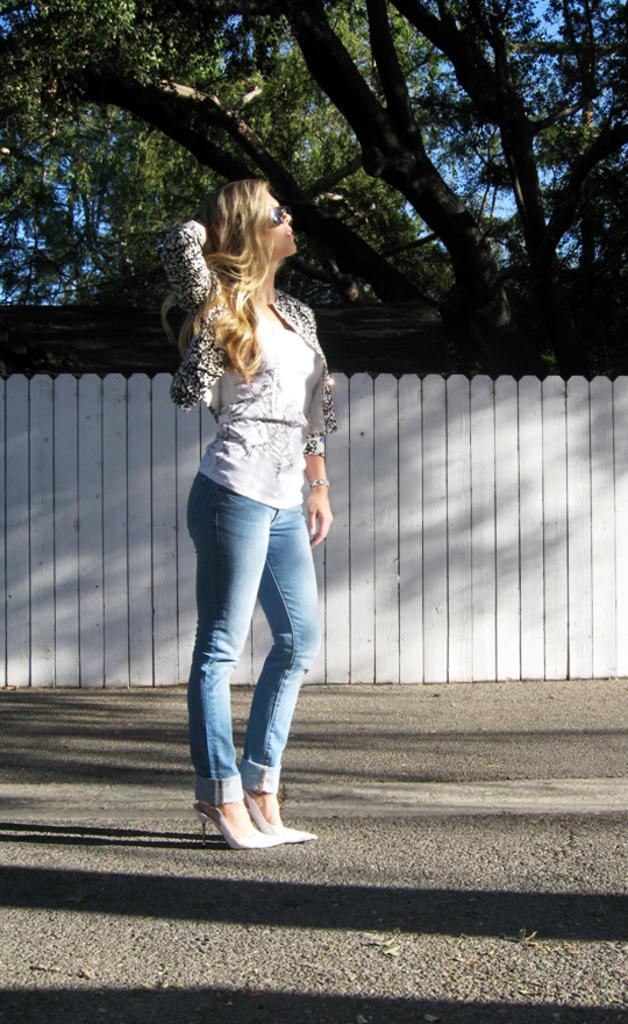What is the person in the image wearing? The person is wearing a dress with black, white, and blue colors. What can be seen in the background of the image? There is a fence, many trees, and the sky visible in the background of the image. What type of crayon is the person using to color the place in the image? There is no crayon or coloring activity present in the image. 